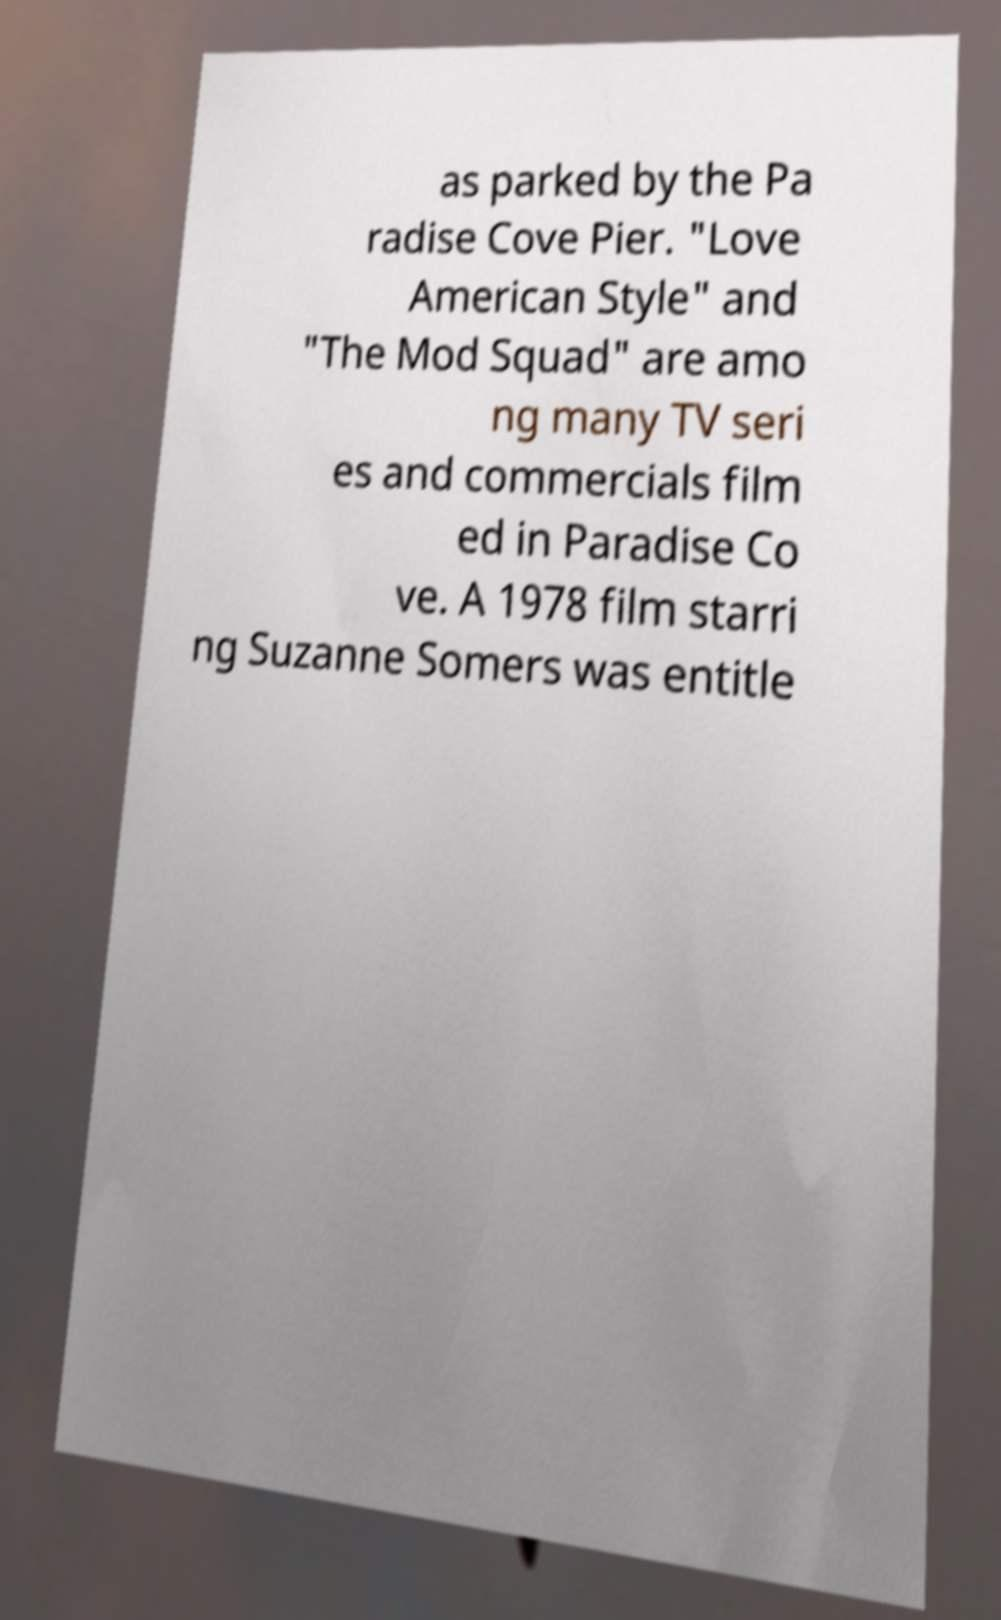For documentation purposes, I need the text within this image transcribed. Could you provide that? as parked by the Pa radise Cove Pier. "Love American Style" and "The Mod Squad" are amo ng many TV seri es and commercials film ed in Paradise Co ve. A 1978 film starri ng Suzanne Somers was entitle 